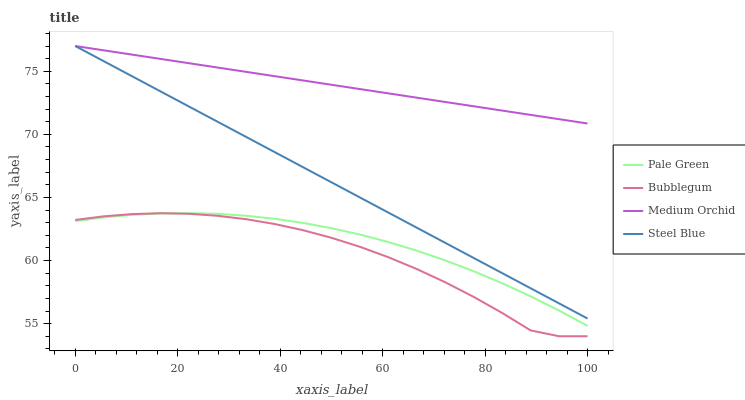Does Bubblegum have the minimum area under the curve?
Answer yes or no. Yes. Does Medium Orchid have the maximum area under the curve?
Answer yes or no. Yes. Does Pale Green have the minimum area under the curve?
Answer yes or no. No. Does Pale Green have the maximum area under the curve?
Answer yes or no. No. Is Steel Blue the smoothest?
Answer yes or no. Yes. Is Bubblegum the roughest?
Answer yes or no. Yes. Is Pale Green the smoothest?
Answer yes or no. No. Is Pale Green the roughest?
Answer yes or no. No. Does Bubblegum have the lowest value?
Answer yes or no. Yes. Does Pale Green have the lowest value?
Answer yes or no. No. Does Steel Blue have the highest value?
Answer yes or no. Yes. Does Pale Green have the highest value?
Answer yes or no. No. Is Pale Green less than Medium Orchid?
Answer yes or no. Yes. Is Steel Blue greater than Pale Green?
Answer yes or no. Yes. Does Medium Orchid intersect Steel Blue?
Answer yes or no. Yes. Is Medium Orchid less than Steel Blue?
Answer yes or no. No. Is Medium Orchid greater than Steel Blue?
Answer yes or no. No. Does Pale Green intersect Medium Orchid?
Answer yes or no. No. 